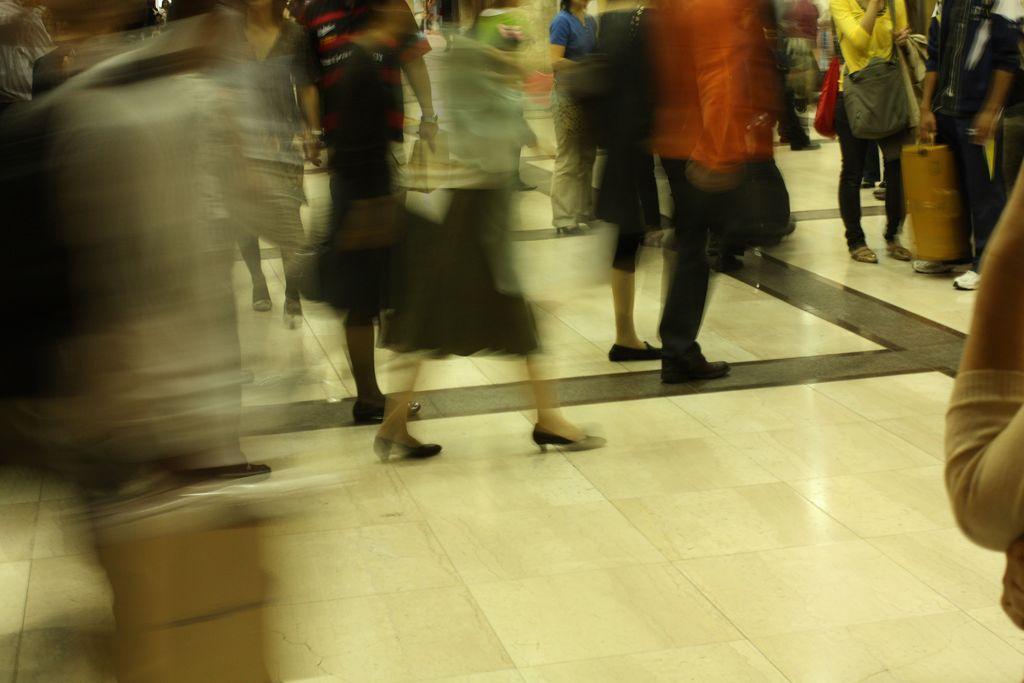Describe this image in one or two sentences. In this image we can see a crowd standing on the floor and some of them are carrying bags in their hands. 